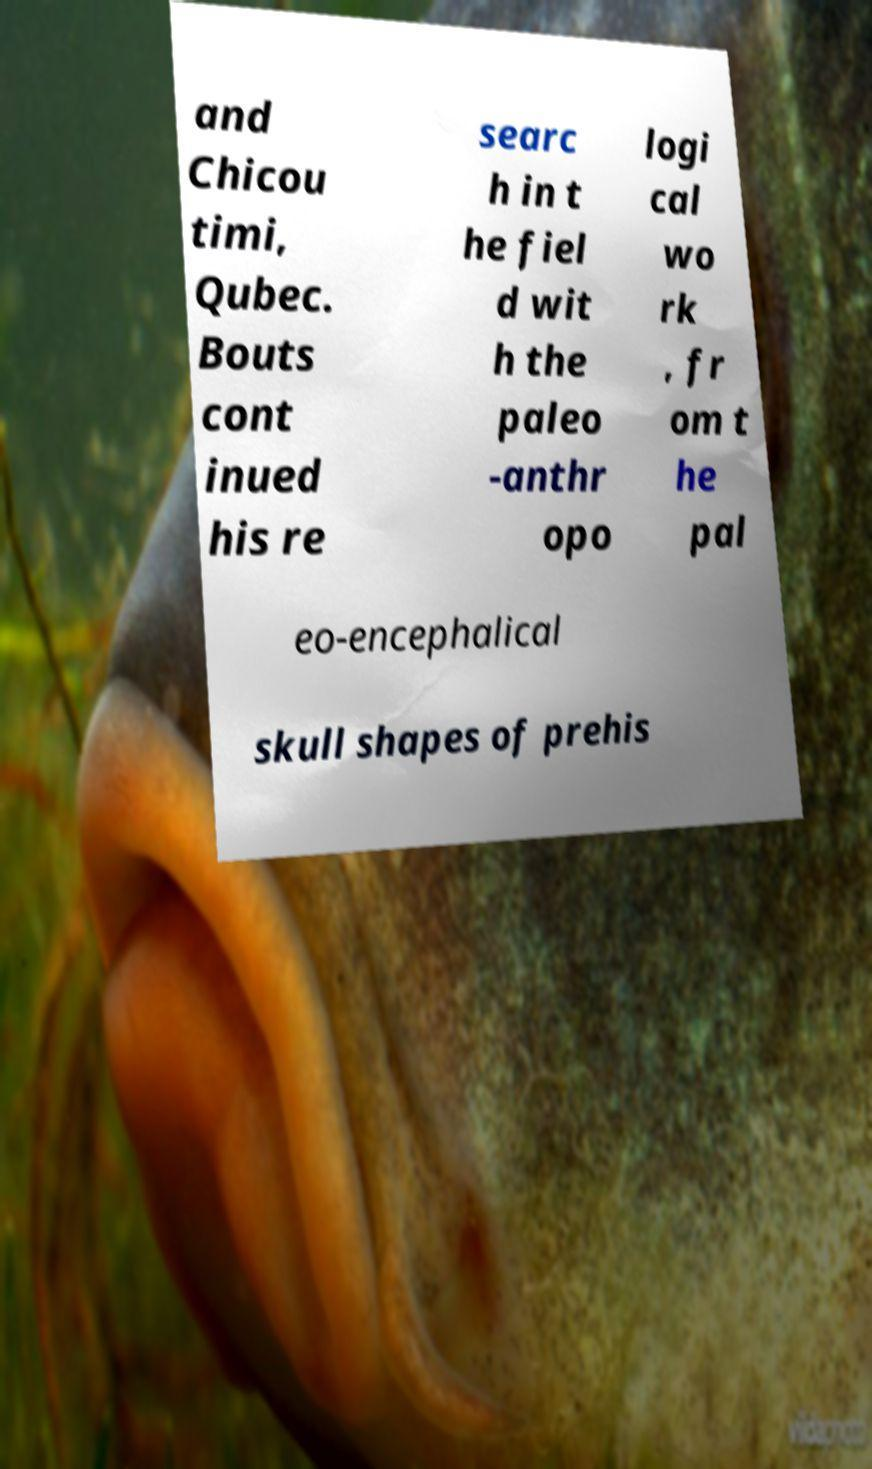What messages or text are displayed in this image? I need them in a readable, typed format. and Chicou timi, Qubec. Bouts cont inued his re searc h in t he fiel d wit h the paleo -anthr opo logi cal wo rk , fr om t he pal eo-encephalical skull shapes of prehis 